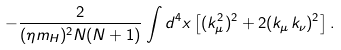Convert formula to latex. <formula><loc_0><loc_0><loc_500><loc_500>- \frac { 2 } { ( \eta m _ { H } ) ^ { 2 } N ( N + 1 ) } \int d ^ { 4 } x \left [ ( { k } _ { \mu } ^ { 2 } ) ^ { 2 } + 2 ( { k } _ { \mu } { k } _ { \nu } ) ^ { 2 } \right ] .</formula> 